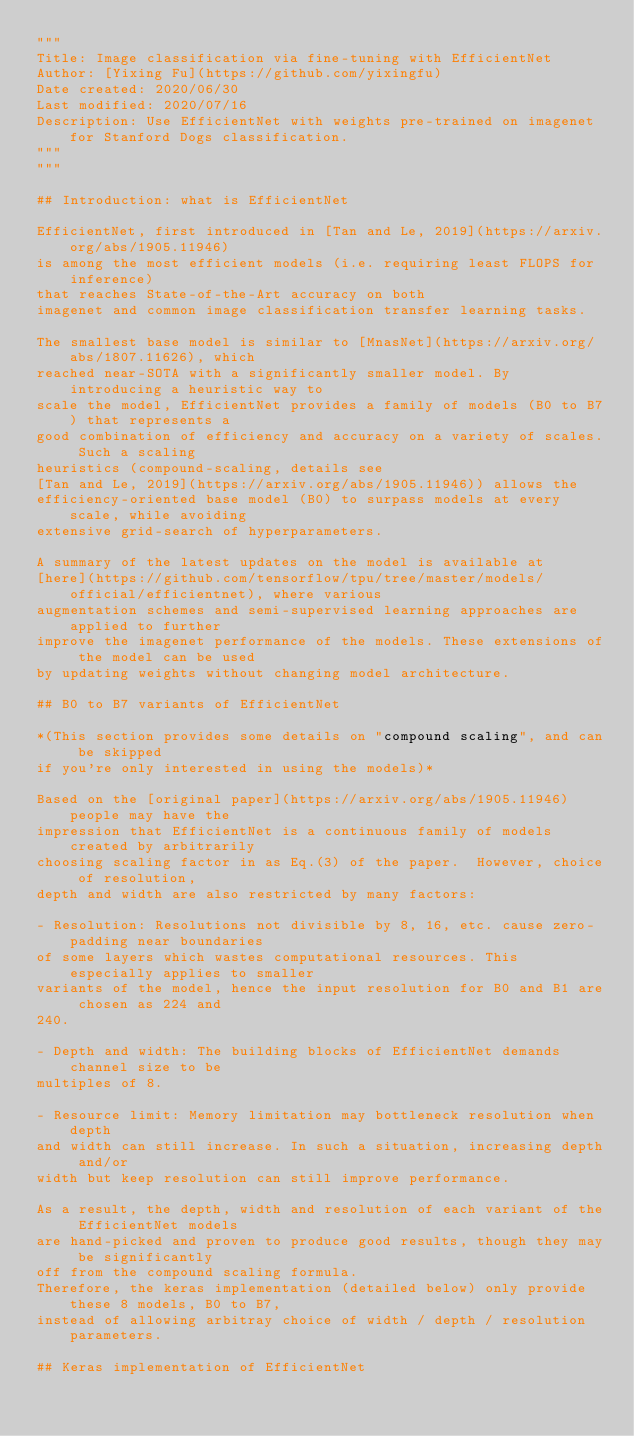Convert code to text. <code><loc_0><loc_0><loc_500><loc_500><_Python_>"""
Title: Image classification via fine-tuning with EfficientNet
Author: [Yixing Fu](https://github.com/yixingfu)
Date created: 2020/06/30
Last modified: 2020/07/16
Description: Use EfficientNet with weights pre-trained on imagenet for Stanford Dogs classification.
"""
"""

## Introduction: what is EfficientNet

EfficientNet, first introduced in [Tan and Le, 2019](https://arxiv.org/abs/1905.11946)
is among the most efficient models (i.e. requiring least FLOPS for inference)
that reaches State-of-the-Art accuracy on both
imagenet and common image classification transfer learning tasks.

The smallest base model is similar to [MnasNet](https://arxiv.org/abs/1807.11626), which
reached near-SOTA with a significantly smaller model. By introducing a heuristic way to
scale the model, EfficientNet provides a family of models (B0 to B7) that represents a
good combination of efficiency and accuracy on a variety of scales. Such a scaling
heuristics (compound-scaling, details see
[Tan and Le, 2019](https://arxiv.org/abs/1905.11946)) allows the
efficiency-oriented base model (B0) to surpass models at every scale, while avoiding
extensive grid-search of hyperparameters.

A summary of the latest updates on the model is available at
[here](https://github.com/tensorflow/tpu/tree/master/models/official/efficientnet), where various
augmentation schemes and semi-supervised learning approaches are applied to further
improve the imagenet performance of the models. These extensions of the model can be used
by updating weights without changing model architecture.

## B0 to B7 variants of EfficientNet

*(This section provides some details on "compound scaling", and can be skipped
if you're only interested in using the models)*

Based on the [original paper](https://arxiv.org/abs/1905.11946) people may have the
impression that EfficientNet is a continuous family of models created by arbitrarily
choosing scaling factor in as Eq.(3) of the paper.  However, choice of resolution,
depth and width are also restricted by many factors:

- Resolution: Resolutions not divisible by 8, 16, etc. cause zero-padding near boundaries
of some layers which wastes computational resources. This especially applies to smaller
variants of the model, hence the input resolution for B0 and B1 are chosen as 224 and
240.

- Depth and width: The building blocks of EfficientNet demands channel size to be
multiples of 8.

- Resource limit: Memory limitation may bottleneck resolution when depth
and width can still increase. In such a situation, increasing depth and/or
width but keep resolution can still improve performance.

As a result, the depth, width and resolution of each variant of the EfficientNet models
are hand-picked and proven to produce good results, though they may be significantly
off from the compound scaling formula.
Therefore, the keras implementation (detailed below) only provide these 8 models, B0 to B7,
instead of allowing arbitray choice of width / depth / resolution parameters.

## Keras implementation of EfficientNet
</code> 